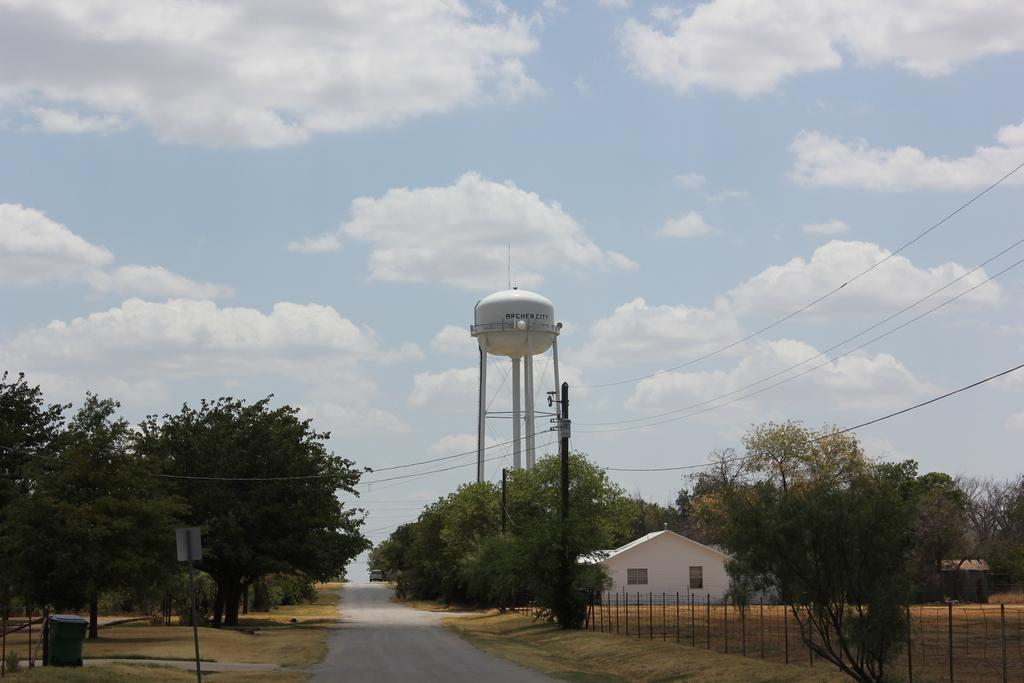What type of structure is visible in the image? There is a house in the image. What other object can be seen in the image? There is a tank in the image. What type of vegetation surrounds the house and tank? There are trees around the house and tank. What else can be seen in the image besides the house, tank, and trees? There are plants in the image. How does the house contribute to the digestion of the plants in the image? The house does not contribute to the digestion of the plants in the image; it is a separate structure. 